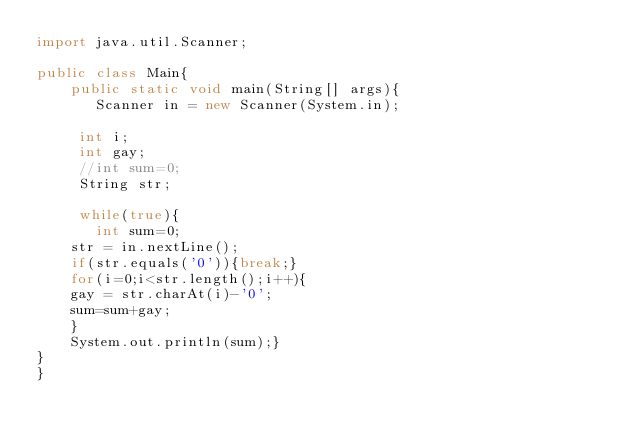Convert code to text. <code><loc_0><loc_0><loc_500><loc_500><_Java_>import java.util.Scanner;
 
public class Main{
    public static void main(String[] args){
       Scanner in = new Scanner(System.in);
	   
	   int i;
	   int gay;
	   //int sum=0;
	   String str;
	   
	   while(true){
		   int sum=0;
		str = in.nextLine();
		if(str.equals('0')){break;}
		for(i=0;i<str.length();i++){
		gay = str.charAt(i)-'0';
		sum=sum+gay;	
		}
		System.out.println(sum);}
}    
}</code> 